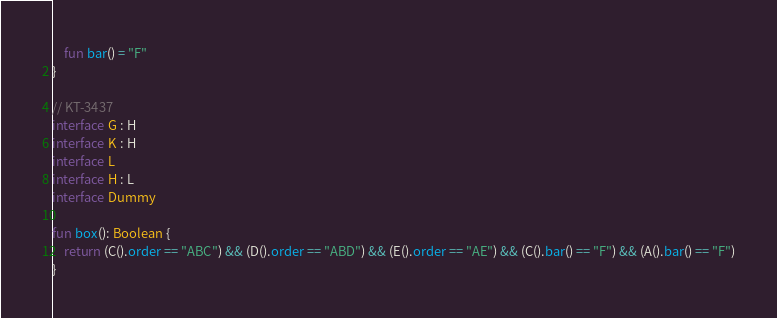<code> <loc_0><loc_0><loc_500><loc_500><_Kotlin_>    fun bar() = "F"
}

// KT-3437
interface G : H
interface K : H
interface L
interface H : L
interface Dummy

fun box(): Boolean {
    return (C().order == "ABC") && (D().order == "ABD") && (E().order == "AE") && (C().bar() == "F") && (A().bar() == "F")
}</code> 